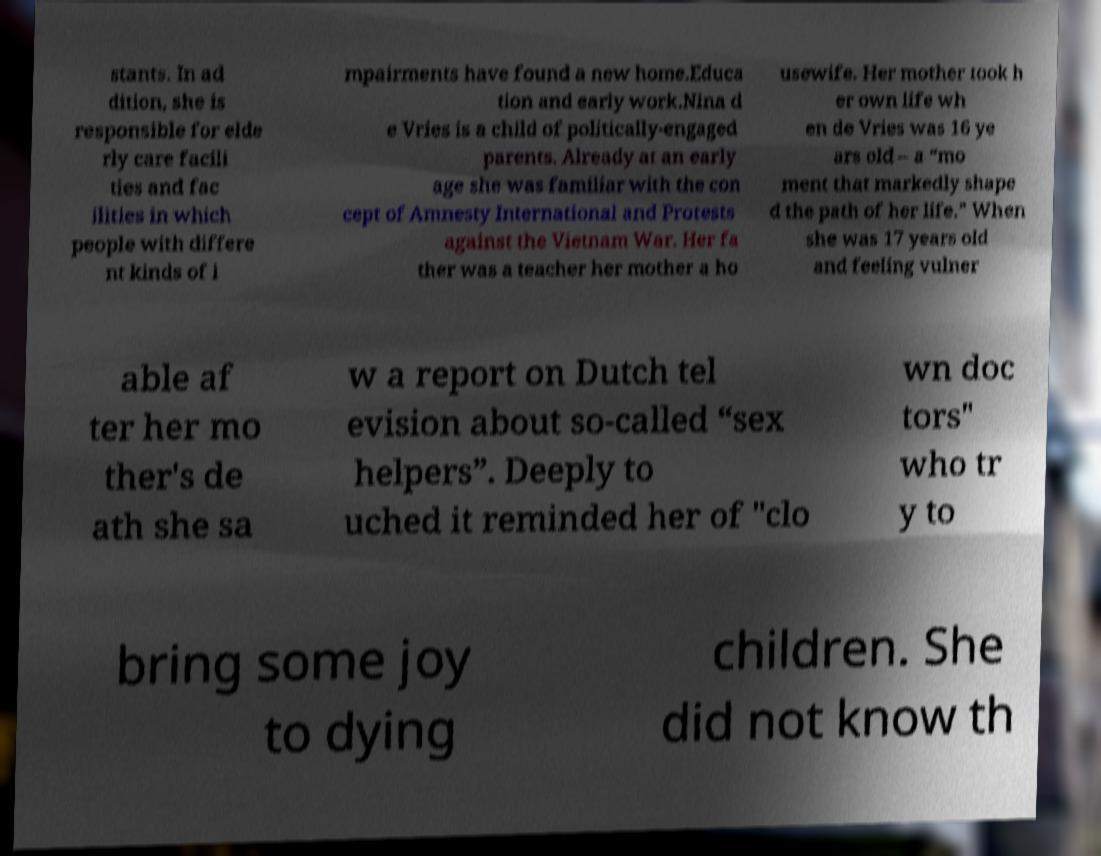Could you assist in decoding the text presented in this image and type it out clearly? stants. In ad dition, she is responsible for elde rly care facili ties and fac ilities in which people with differe nt kinds of i mpairments have found a new home.Educa tion and early work.Nina d e Vries is a child of politically-engaged parents. Already at an early age she was familiar with the con cept of Amnesty International and Protests against the Vietnam War. Her fa ther was a teacher her mother a ho usewife. Her mother took h er own life wh en de Vries was 16 ye ars old – a “mo ment that markedly shape d the path of her life.” When she was 17 years old and feeling vulner able af ter her mo ther's de ath she sa w a report on Dutch tel evision about so-called “sex helpers”. Deeply to uched it reminded her of "clo wn doc tors" who tr y to bring some joy to dying children. She did not know th 